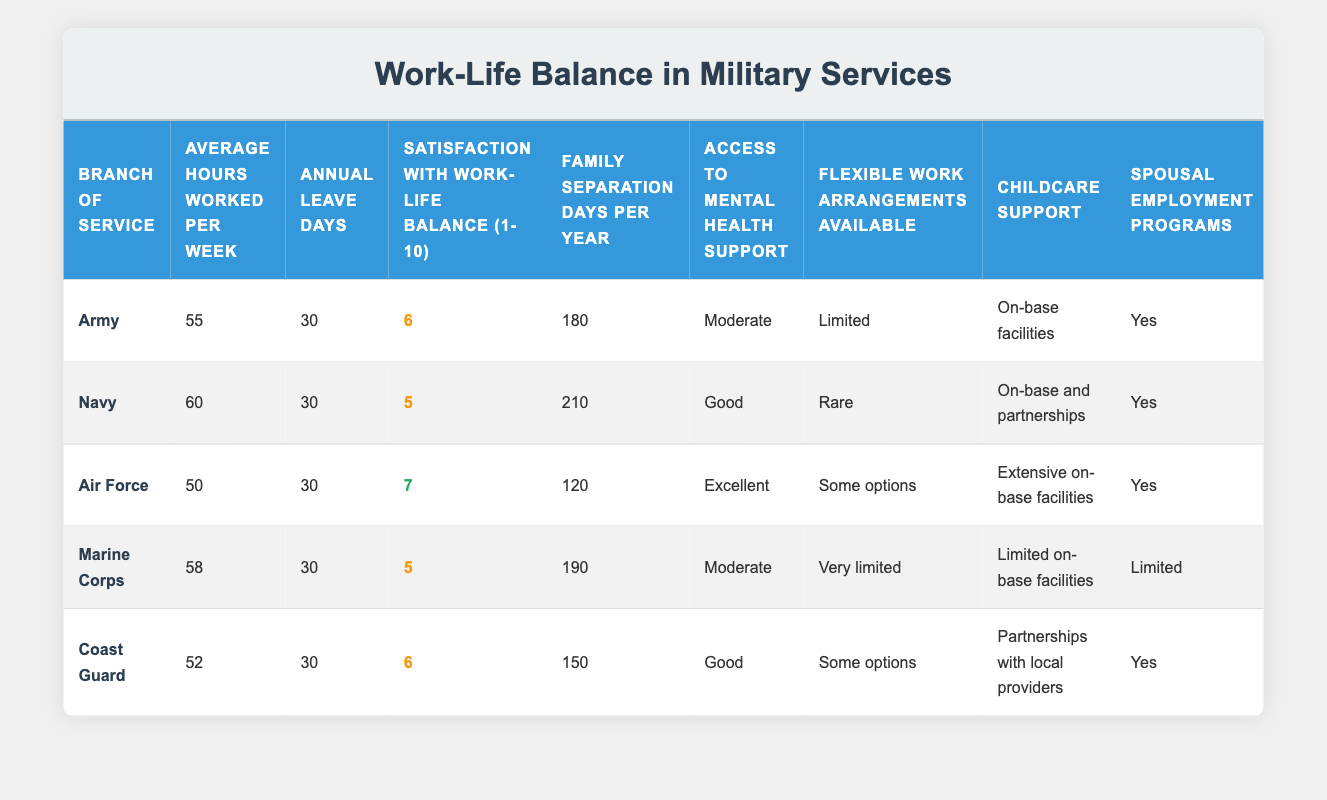What is the average number of hours worked per week in the Navy? The table lists the average hours worked per week for each branch of service. For the Navy, it states that the average is 60 hours per week.
Answer: 60 Which branch of service has the highest satisfaction with work-life balance? In the satisfaction column, the Air Force has the highest score at 7, while other branches have lower satisfaction scores of 5 or 6.
Answer: Air Force How many family separation days does the Army experience per year? Looking at the table, the Army has 180 family separation days per year listed under that column.
Answer: 180 Is flexible work arrangement availability better in the Air Force compared to the Marine Corps? The Air Force offers "Some options" for flexible work arrangements, while the Marine Corps offers "Very limited." Thus, the Air Force has better availability.
Answer: Yes What is the difference in average hours worked per week between the Navy and the Air Force? The average hours worked per week for the Navy is 60, while for the Air Force it is 50. The difference is calculated as 60 - 50 = 10 hours.
Answer: 10 Do all branches provide spouse employment programs? In the table, it shows that the Army, Navy, Air Force, Coast Guard, and Marine Corps all have "Yes" listed for spousal employment programs. Therefore, the answer is that they do all provide it.
Answer: Yes What is the average satisfaction score with work-life balance across all branches? To find the average satisfaction score, we add the scores for all branches: (6 + 5 + 7 + 5 + 6) = 29. Then, dividing by the number of branches (5), the average is 29 / 5 = 5.8.
Answer: 5.8 How does the Access to Mental Health Support in the Coast Guard compare to the Marine Corps? The Coast Guard has "Good" access, whereas the Marine Corps has "Moderate." Since "Good" is better than "Moderate," the Coast Guard has better access.
Answer: Yes What branch has the least number of family separation days per year? The table shows that the Air Force has the least family separation days at 120 compared to others.
Answer: Air Force 